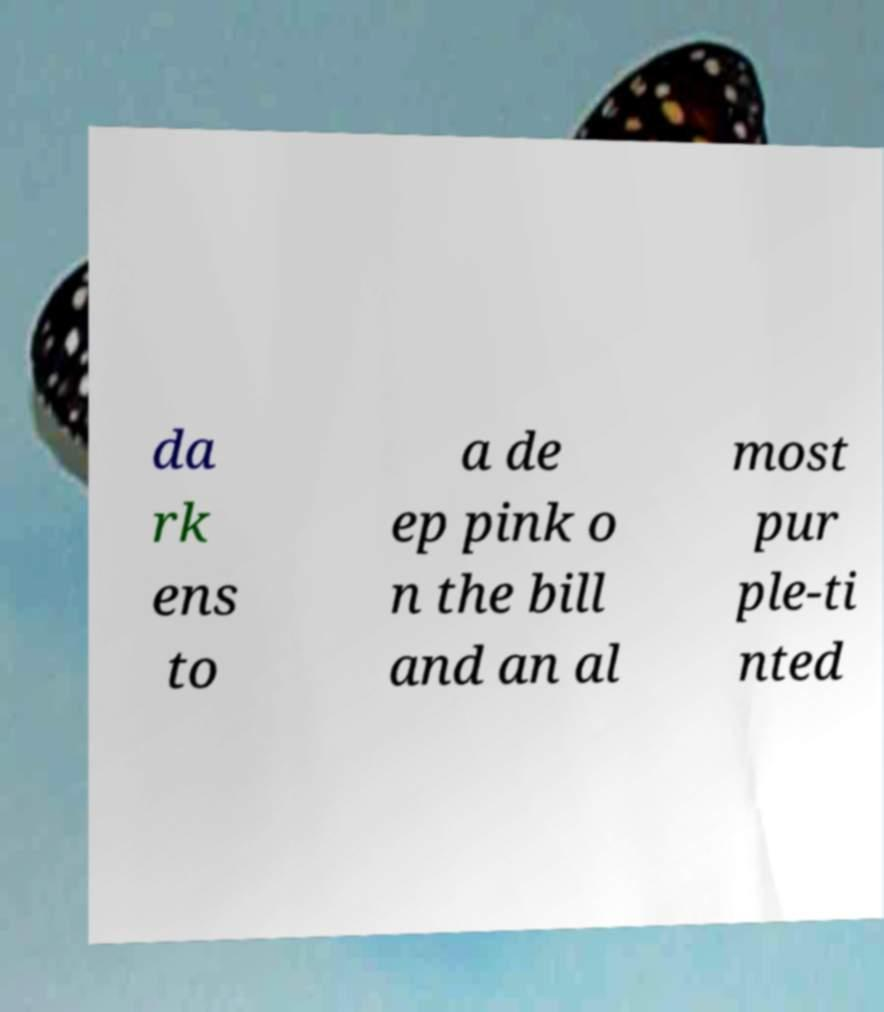What messages or text are displayed in this image? I need them in a readable, typed format. da rk ens to a de ep pink o n the bill and an al most pur ple-ti nted 